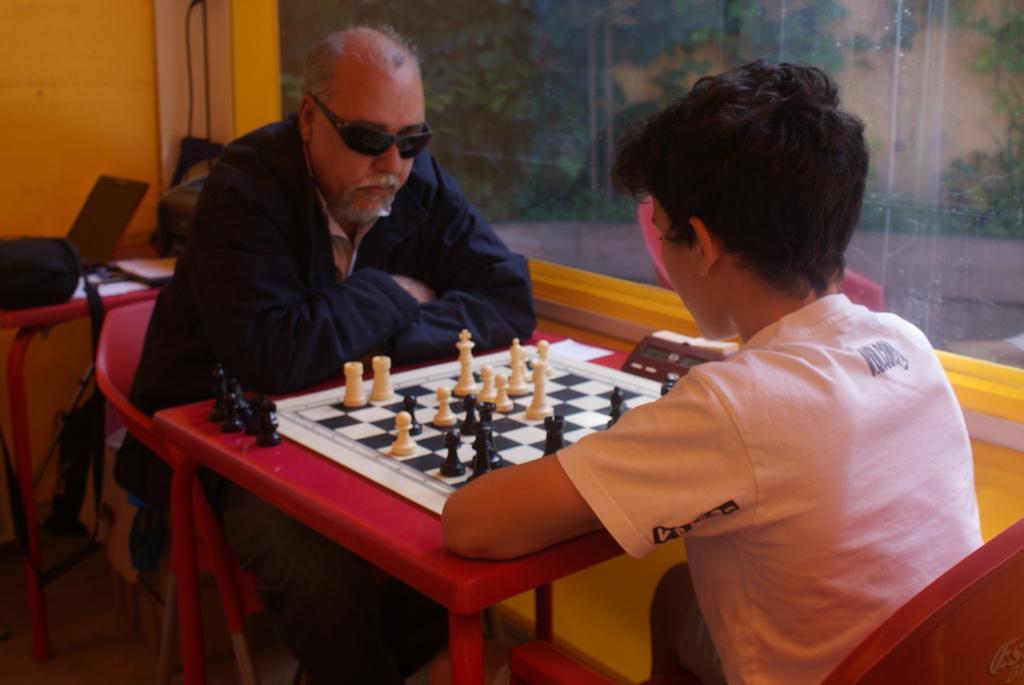Can you describe this image briefly? In this picture we can see man and boy sitting on chair and playing chess board placed on table with timer and in background we can see bag, papers, wall with glass, trees. 